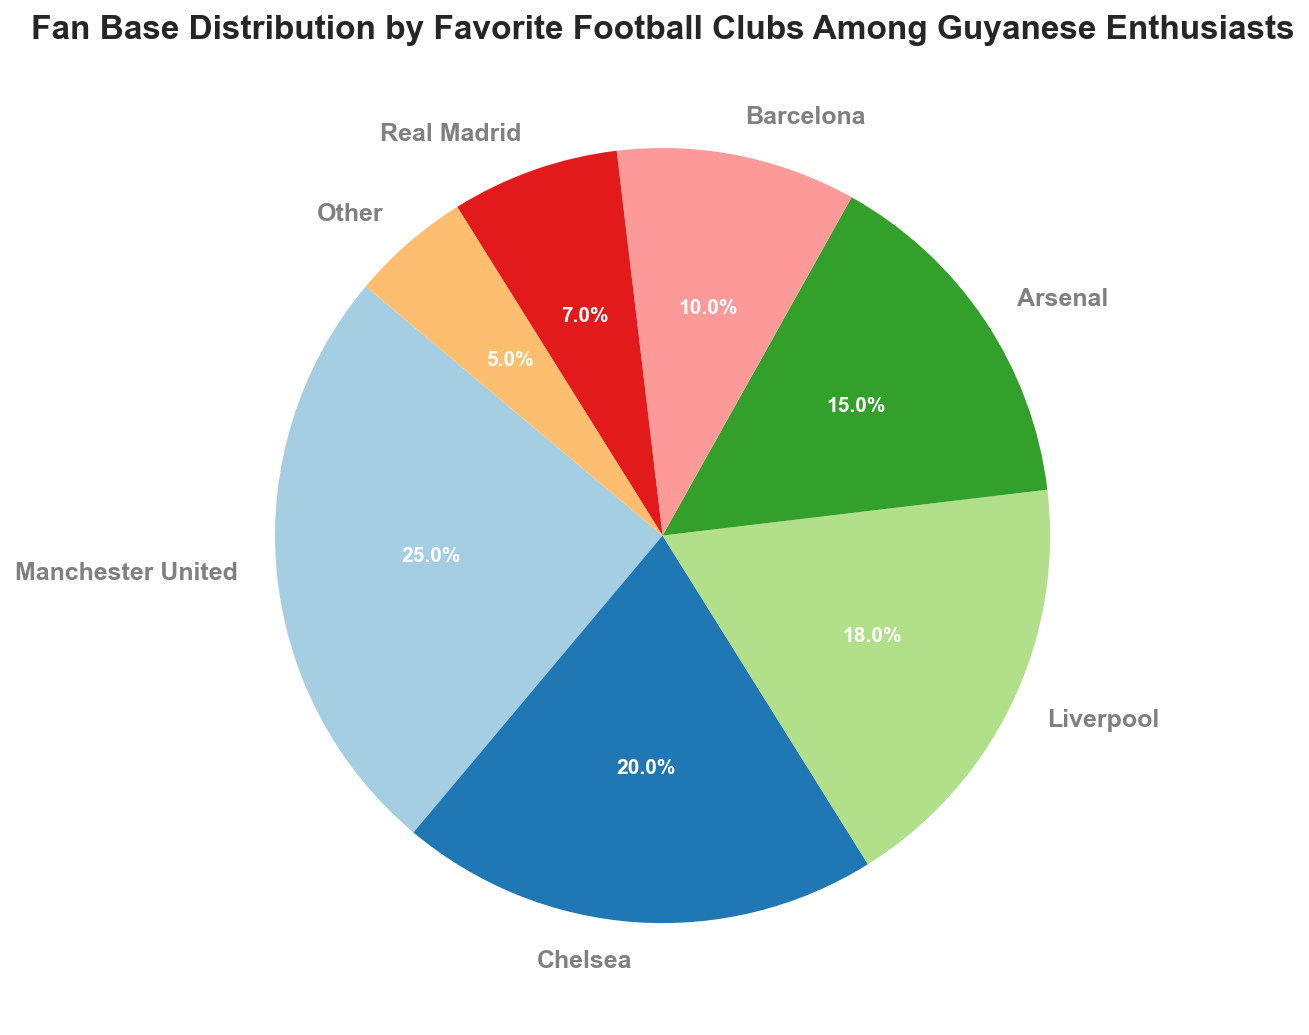Which football club has the largest fan base among Guyanese enthusiasts? The pie chart shows the distribution of football clubs by the fan base percentage. By checking the largest section, we can see that Manchester United has the largest fan base with 25%.
Answer: Manchester United Which two football clubs have a combined fan base percentage of 35%? From the pie chart, we see that Chelsea has 20% and Barcelona has 10%, and adding them together gives us 30%. Then looking at Arsenal with 15%, combining Arsenal and Chelsea, we get 35%.
Answer: Chelsea and Arsenal How much larger is the fan base of Arsenal compared to Barcelona? The fan base for Arsenal is 15% and for Barcelona is 10%. The difference between Arsenal's and Barcelona's fan bases is 15% - 10% = 5%.
Answer: 5% Which is the least favorite club among Guyanese fans, and what percentage of fans support it? By examining the pie chart, the 'Other' category has the smallest percentage of fans, which is 5%.
Answer: Other, 5% What is the total fan base percentage for English clubs (Manchester United, Chelsea, Liverpool, Arsenal)? Summing the percentages of the English clubs: Manchester United (25%), Chelsea (20%), Liverpool (18%), and Arsenal (15%), we get 25% + 20% + 18% + 15% = 78%.
Answer: 78% How does the fan base of Real Madrid compare to that of Liverpool? From the pie chart, Real Madrid has a 7% fan base while Liverpool has 18%. Therefore, Liverpool's fan base is significantly larger.
Answer: Liverpool's fan base is larger Which three football clubs together constitute just over half of the total fan base? By looking at the pie chart percentages, we identify the clubs with percentages over a cumulative 50%. Manchester United (25%), Chelsea (20%), and Liverpool (18%) together make 25% + 20% + 18% = 63%, which is just over half.
Answer: Manchester United, Chelsea, Liverpool If you were to combine the fan bases of both Spanish clubs, would they surpass Chelsea's fan base? The Spanish clubs are Barcelona with 10% and Real Madrid with 7%. Combining these, we get 10% + 7% = 17%, which is less than Chelsea's 20%.
Answer: No, they would not What is the average percentage of the fan base for the non-English clubs listed? The non-English clubs listed are Barcelona (10%) and Real Madrid (7%). The average is calculated by (10% + 7%) / 2 = 8.5%.
Answer: 8.5% What fraction of the total fan base do Manchester United and Liverpool account for? Manchester United accounts for 25% and Liverpool for 18% of the fan base. Together they account for 25% + 18% = 43% of the total fan base. As a fraction, this is 43/100 which simplifies to 43/100.
Answer: 43/100 